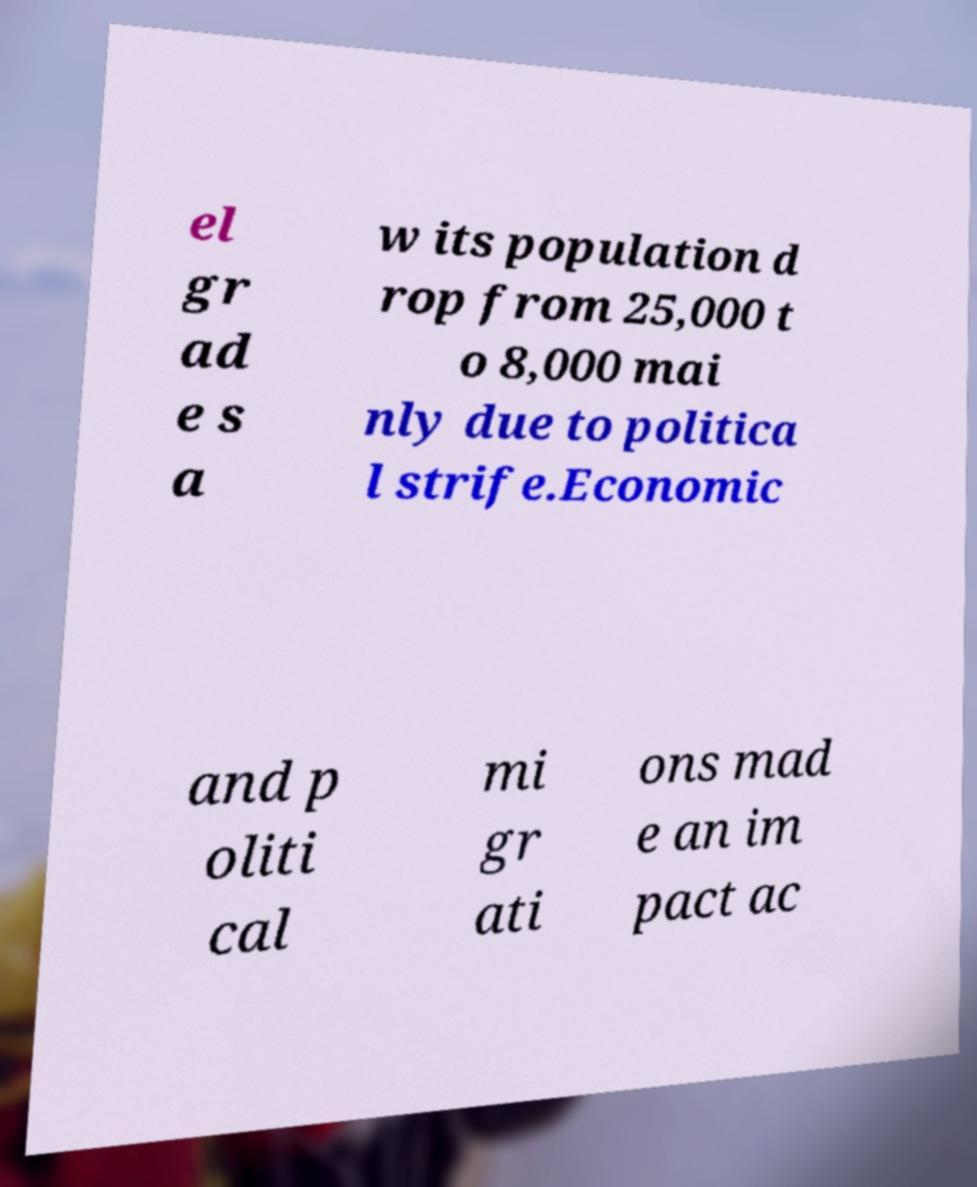Can you accurately transcribe the text from the provided image for me? el gr ad e s a w its population d rop from 25,000 t o 8,000 mai nly due to politica l strife.Economic and p oliti cal mi gr ati ons mad e an im pact ac 